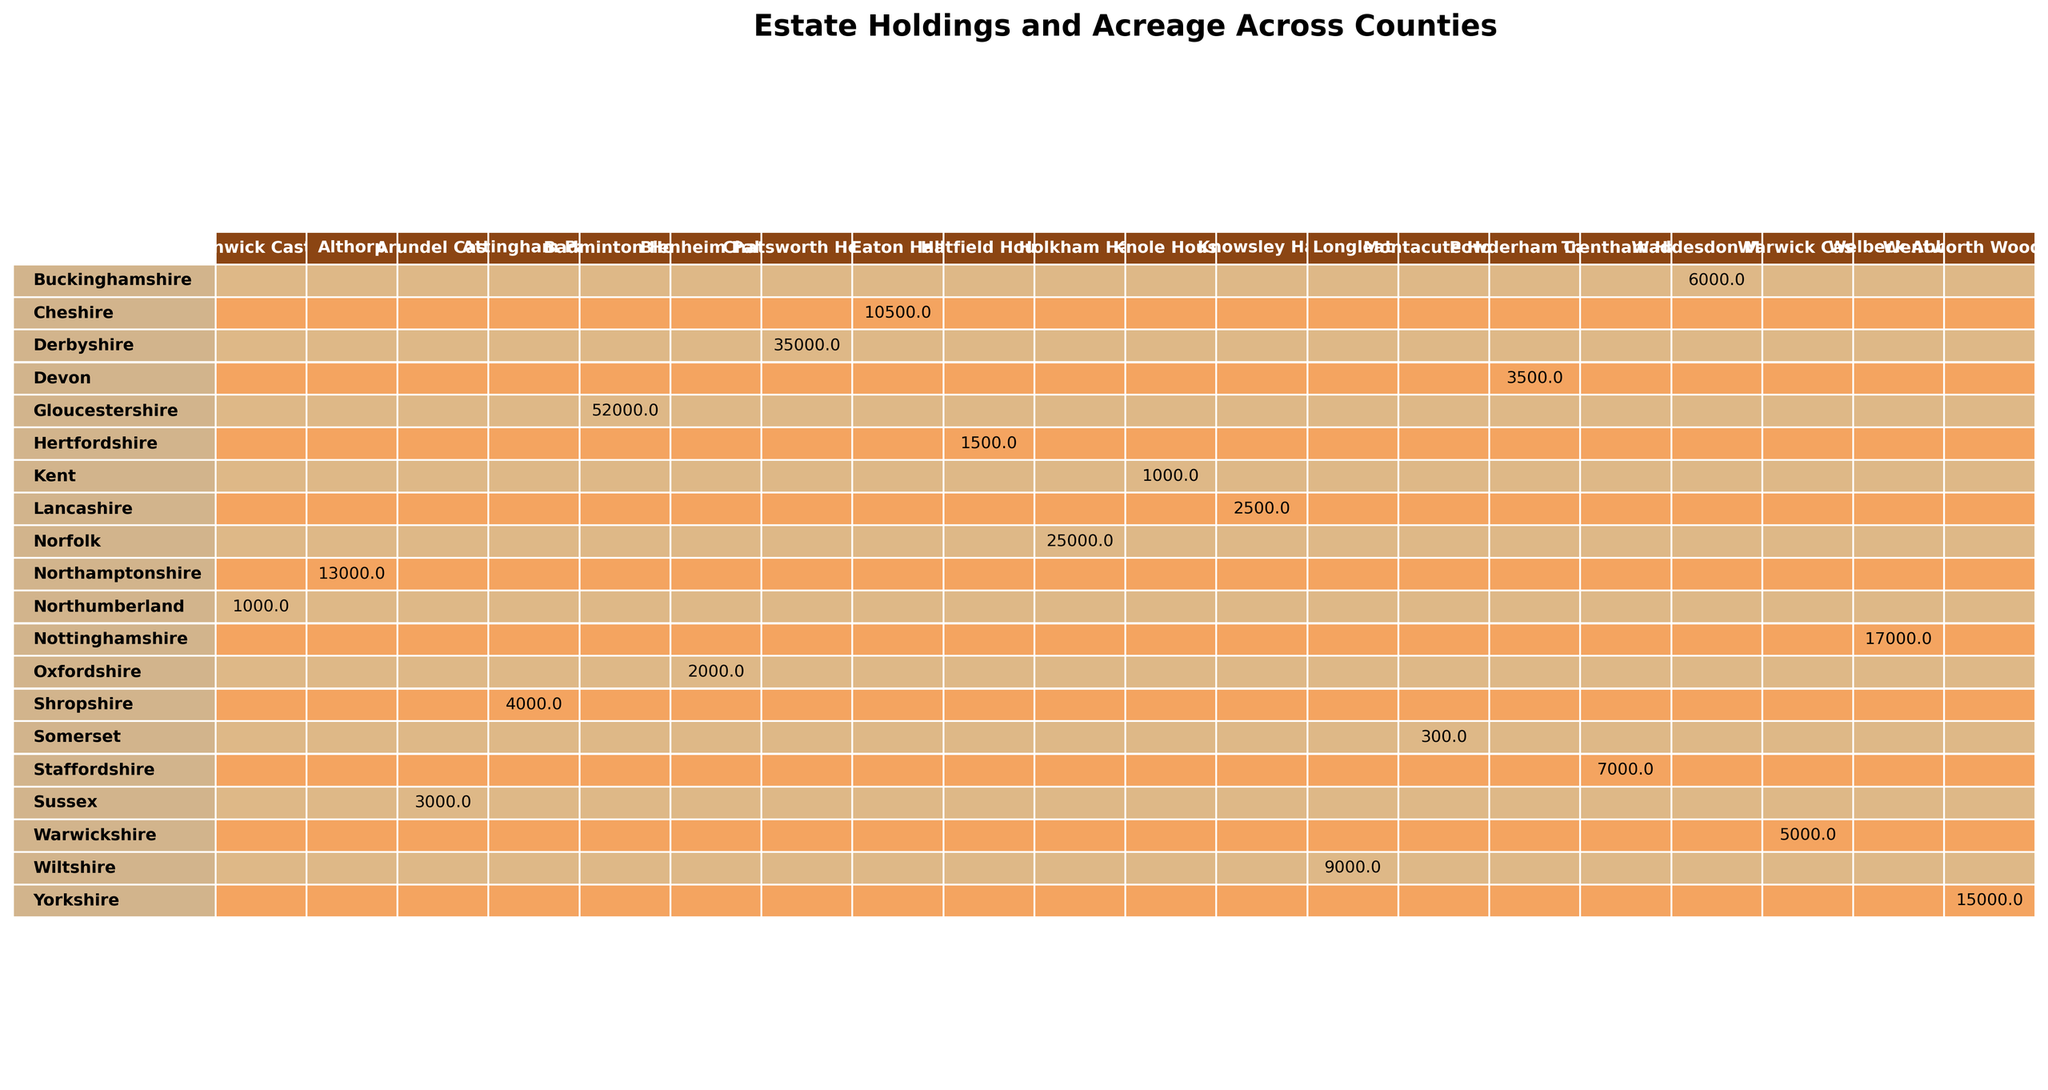What is the largest estate by acreage in the table? The largest estate is Badminton House located in Gloucestershire, with an acreage of 52,000.
Answer: 52,000 Which county has the least acreage for its estate? The county with the least acreage is Somerset, with Montacute House having only 300 acres.
Answer: 300 What is the total acreage of estates in Yorkshire and Derbyshire? Yorkshire has 15,000 acres (Wentworth Woodhouse) and Derbyshire has 35,000 acres (Chatsworth House), so summing them gives 15,000 + 35,000 = 50,000 acres.
Answer: 50,000 Are there any counties with estates having an acreage over 40,000? Yes, Gloucestershire has Badminton House with 52,000 acres, which is over 40,000.
Answer: Yes How many estates are there in counties with an acreage less than 5,000? The counties with estates below 5,000 acres are Oxfordshire (2,000), Kent (1,000), Sussex (3,000), Lancashire (2,500), and Somerset (300), totaling 5 estates.
Answer: 5 What is the average acreage of estates in Hertfordshire and Buckinghamshire? Hertfordshire has 1,500 (Hatfield House) and Buckinghamshire has 6,000 (Waddesdon Manor), making the total 1,500 + 6,000 = 7,500. The average is 7,500 / 2 = 3,750.
Answer: 3,750 Which estate has a larger acreage, Knole House or Longleat? Knole House has 1,000 acres and Longleat has 9,000 acres. Therefore, Longleat is larger.
Answer: Longleat What is the total combined acreage of estates located in Northumberland and Nottinghamshire? Northumberland has 1,000 acres (Alnwick Castle) and Nottinghamshire has 17,000 acres (Welbeck Abbey), summing them gives 1,000 + 17,000 = 18,000 acres.
Answer: 18,000 Is there a county that has an estate with exactly 10,000 acres? No, there are no estates listed with exactly 10,000 acres in the table.
Answer: No How does the total acreage of estates in the South compare to those in the North? The total acreage for Southern counties (Kent, Sussex, Hampshire) is 1,000 + 3,000 + 0 = 4,000, while the Northern counties (Northumberland, Yorkshire, etc.) sum up to more than 70,000 acres combined, showing the South has considerably less.
Answer: South has less What is the difference in acreage between the largest and smallest estate? The largest estate is Badminton House with 52,000 acres, and the smallest is Somerset's Montacute House with 300 acres, so the difference is 52,000 - 300 = 51,700 acres.
Answer: 51,700 